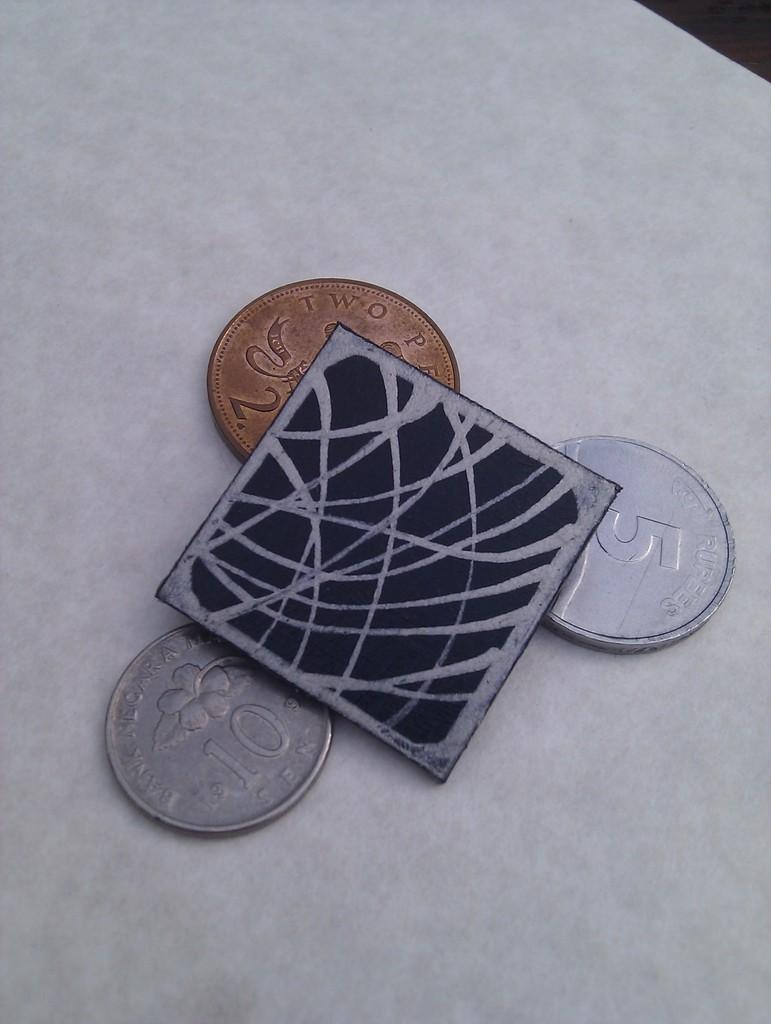<image>
Summarize the visual content of the image. Three coins, with the numbers 2, 5, and 10 on them, sit around a square object. 